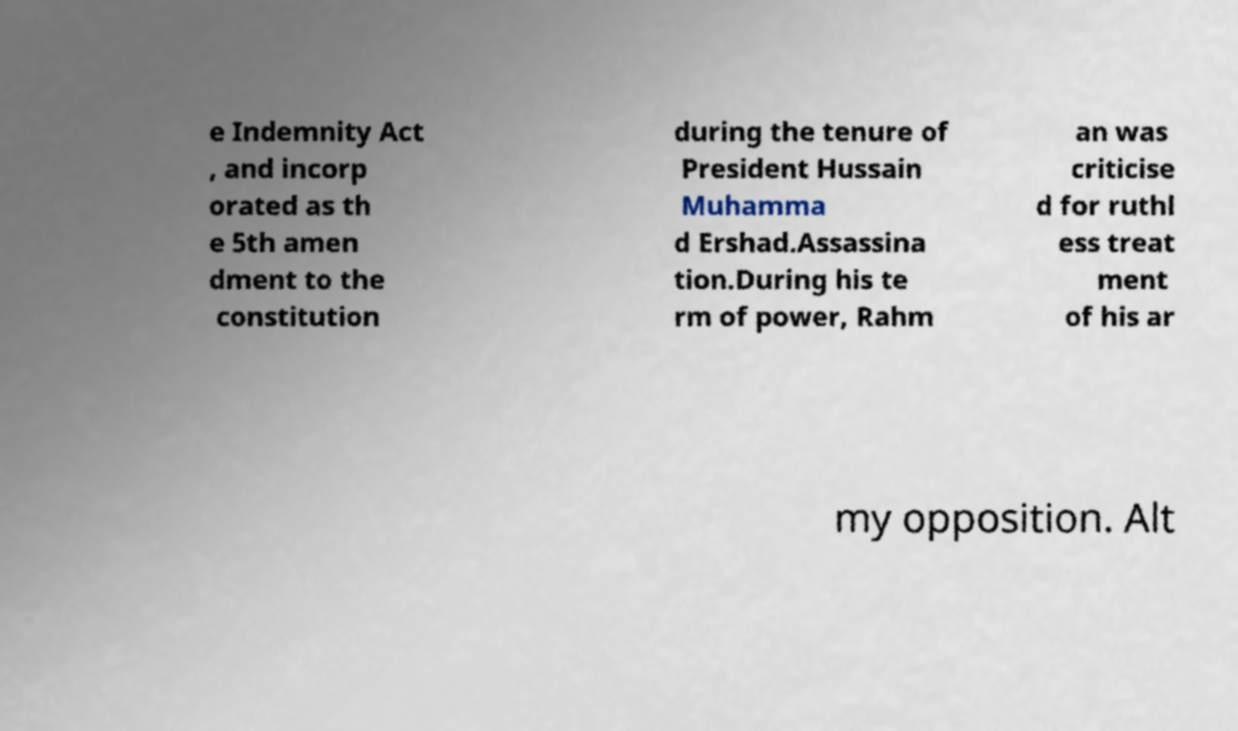Could you assist in decoding the text presented in this image and type it out clearly? e Indemnity Act , and incorp orated as th e 5th amen dment to the constitution during the tenure of President Hussain Muhamma d Ershad.Assassina tion.During his te rm of power, Rahm an was criticise d for ruthl ess treat ment of his ar my opposition. Alt 